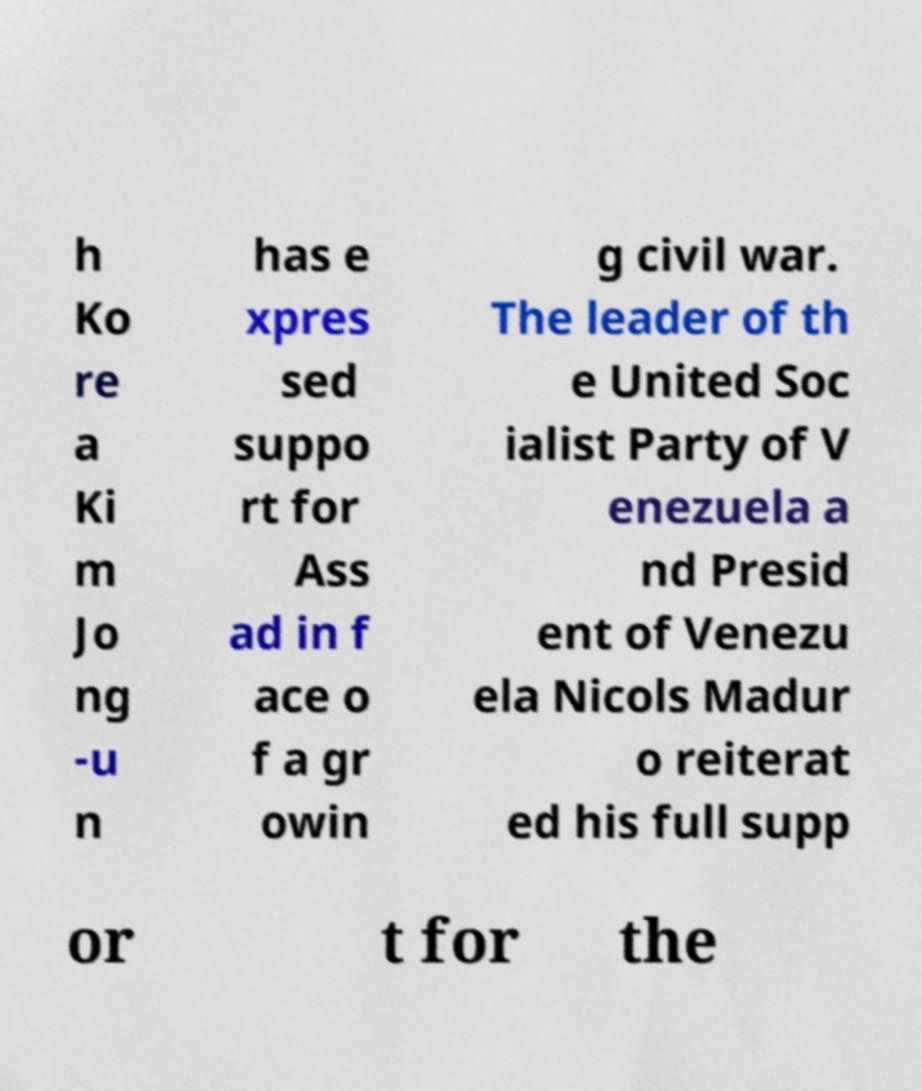What messages or text are displayed in this image? I need them in a readable, typed format. h Ko re a Ki m Jo ng -u n has e xpres sed suppo rt for Ass ad in f ace o f a gr owin g civil war. The leader of th e United Soc ialist Party of V enezuela a nd Presid ent of Venezu ela Nicols Madur o reiterat ed his full supp or t for the 